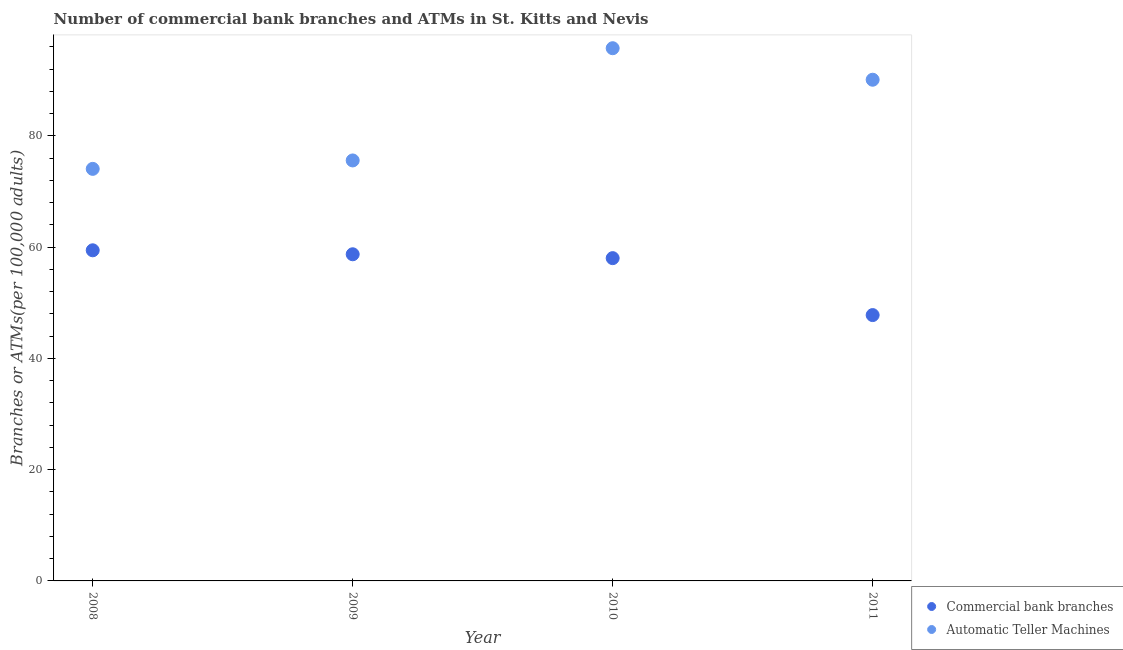Is the number of dotlines equal to the number of legend labels?
Keep it short and to the point. Yes. What is the number of commercal bank branches in 2009?
Your answer should be very brief. 58.73. Across all years, what is the maximum number of atms?
Your answer should be compact. 95.77. Across all years, what is the minimum number of atms?
Offer a very short reply. 74.08. In which year was the number of atms minimum?
Your response must be concise. 2008. What is the total number of atms in the graph?
Your response must be concise. 335.55. What is the difference between the number of atms in 2010 and that in 2011?
Provide a succinct answer. 5.67. What is the difference between the number of atms in 2010 and the number of commercal bank branches in 2009?
Offer a very short reply. 37.04. What is the average number of atms per year?
Ensure brevity in your answer.  83.89. In the year 2010, what is the difference between the number of commercal bank branches and number of atms?
Your answer should be compact. -37.74. What is the ratio of the number of atms in 2009 to that in 2011?
Make the answer very short. 0.84. What is the difference between the highest and the second highest number of atms?
Give a very brief answer. 5.67. What is the difference between the highest and the lowest number of atms?
Your answer should be very brief. 21.69. In how many years, is the number of commercal bank branches greater than the average number of commercal bank branches taken over all years?
Offer a very short reply. 3. Is the sum of the number of atms in 2008 and 2009 greater than the maximum number of commercal bank branches across all years?
Offer a very short reply. Yes. Is the number of commercal bank branches strictly greater than the number of atms over the years?
Make the answer very short. No. Is the number of atms strictly less than the number of commercal bank branches over the years?
Your answer should be very brief. No. How many dotlines are there?
Offer a very short reply. 2. What is the difference between two consecutive major ticks on the Y-axis?
Keep it short and to the point. 20. Where does the legend appear in the graph?
Ensure brevity in your answer.  Bottom right. How many legend labels are there?
Offer a terse response. 2. How are the legend labels stacked?
Make the answer very short. Vertical. What is the title of the graph?
Offer a terse response. Number of commercial bank branches and ATMs in St. Kitts and Nevis. Does "Measles" appear as one of the legend labels in the graph?
Keep it short and to the point. No. What is the label or title of the Y-axis?
Provide a short and direct response. Branches or ATMs(per 100,0 adults). What is the Branches or ATMs(per 100,000 adults) in Commercial bank branches in 2008?
Your answer should be compact. 59.44. What is the Branches or ATMs(per 100,000 adults) in Automatic Teller Machines in 2008?
Ensure brevity in your answer.  74.08. What is the Branches or ATMs(per 100,000 adults) in Commercial bank branches in 2009?
Offer a very short reply. 58.73. What is the Branches or ATMs(per 100,000 adults) of Automatic Teller Machines in 2009?
Your response must be concise. 75.59. What is the Branches or ATMs(per 100,000 adults) in Commercial bank branches in 2010?
Make the answer very short. 58.03. What is the Branches or ATMs(per 100,000 adults) of Automatic Teller Machines in 2010?
Offer a very short reply. 95.77. What is the Branches or ATMs(per 100,000 adults) of Commercial bank branches in 2011?
Provide a succinct answer. 47.79. What is the Branches or ATMs(per 100,000 adults) of Automatic Teller Machines in 2011?
Give a very brief answer. 90.1. Across all years, what is the maximum Branches or ATMs(per 100,000 adults) in Commercial bank branches?
Make the answer very short. 59.44. Across all years, what is the maximum Branches or ATMs(per 100,000 adults) in Automatic Teller Machines?
Offer a terse response. 95.77. Across all years, what is the minimum Branches or ATMs(per 100,000 adults) of Commercial bank branches?
Ensure brevity in your answer.  47.79. Across all years, what is the minimum Branches or ATMs(per 100,000 adults) in Automatic Teller Machines?
Offer a terse response. 74.08. What is the total Branches or ATMs(per 100,000 adults) of Commercial bank branches in the graph?
Offer a terse response. 223.99. What is the total Branches or ATMs(per 100,000 adults) in Automatic Teller Machines in the graph?
Offer a very short reply. 335.55. What is the difference between the Branches or ATMs(per 100,000 adults) of Commercial bank branches in 2008 and that in 2009?
Offer a terse response. 0.71. What is the difference between the Branches or ATMs(per 100,000 adults) in Automatic Teller Machines in 2008 and that in 2009?
Your answer should be compact. -1.51. What is the difference between the Branches or ATMs(per 100,000 adults) of Commercial bank branches in 2008 and that in 2010?
Offer a very short reply. 1.41. What is the difference between the Branches or ATMs(per 100,000 adults) in Automatic Teller Machines in 2008 and that in 2010?
Your answer should be compact. -21.69. What is the difference between the Branches or ATMs(per 100,000 adults) in Commercial bank branches in 2008 and that in 2011?
Your response must be concise. 11.65. What is the difference between the Branches or ATMs(per 100,000 adults) of Automatic Teller Machines in 2008 and that in 2011?
Offer a very short reply. -16.02. What is the difference between the Branches or ATMs(per 100,000 adults) in Commercial bank branches in 2009 and that in 2010?
Ensure brevity in your answer.  0.7. What is the difference between the Branches or ATMs(per 100,000 adults) in Automatic Teller Machines in 2009 and that in 2010?
Provide a short and direct response. -20.18. What is the difference between the Branches or ATMs(per 100,000 adults) in Commercial bank branches in 2009 and that in 2011?
Make the answer very short. 10.93. What is the difference between the Branches or ATMs(per 100,000 adults) of Automatic Teller Machines in 2009 and that in 2011?
Offer a terse response. -14.51. What is the difference between the Branches or ATMs(per 100,000 adults) in Commercial bank branches in 2010 and that in 2011?
Offer a very short reply. 10.24. What is the difference between the Branches or ATMs(per 100,000 adults) of Automatic Teller Machines in 2010 and that in 2011?
Offer a very short reply. 5.67. What is the difference between the Branches or ATMs(per 100,000 adults) in Commercial bank branches in 2008 and the Branches or ATMs(per 100,000 adults) in Automatic Teller Machines in 2009?
Make the answer very short. -16.15. What is the difference between the Branches or ATMs(per 100,000 adults) of Commercial bank branches in 2008 and the Branches or ATMs(per 100,000 adults) of Automatic Teller Machines in 2010?
Keep it short and to the point. -36.33. What is the difference between the Branches or ATMs(per 100,000 adults) of Commercial bank branches in 2008 and the Branches or ATMs(per 100,000 adults) of Automatic Teller Machines in 2011?
Your answer should be very brief. -30.66. What is the difference between the Branches or ATMs(per 100,000 adults) of Commercial bank branches in 2009 and the Branches or ATMs(per 100,000 adults) of Automatic Teller Machines in 2010?
Provide a succinct answer. -37.04. What is the difference between the Branches or ATMs(per 100,000 adults) of Commercial bank branches in 2009 and the Branches or ATMs(per 100,000 adults) of Automatic Teller Machines in 2011?
Your answer should be very brief. -31.38. What is the difference between the Branches or ATMs(per 100,000 adults) of Commercial bank branches in 2010 and the Branches or ATMs(per 100,000 adults) of Automatic Teller Machines in 2011?
Ensure brevity in your answer.  -32.07. What is the average Branches or ATMs(per 100,000 adults) of Commercial bank branches per year?
Ensure brevity in your answer.  56. What is the average Branches or ATMs(per 100,000 adults) in Automatic Teller Machines per year?
Make the answer very short. 83.89. In the year 2008, what is the difference between the Branches or ATMs(per 100,000 adults) of Commercial bank branches and Branches or ATMs(per 100,000 adults) of Automatic Teller Machines?
Your answer should be very brief. -14.64. In the year 2009, what is the difference between the Branches or ATMs(per 100,000 adults) of Commercial bank branches and Branches or ATMs(per 100,000 adults) of Automatic Teller Machines?
Ensure brevity in your answer.  -16.87. In the year 2010, what is the difference between the Branches or ATMs(per 100,000 adults) in Commercial bank branches and Branches or ATMs(per 100,000 adults) in Automatic Teller Machines?
Your answer should be very brief. -37.74. In the year 2011, what is the difference between the Branches or ATMs(per 100,000 adults) in Commercial bank branches and Branches or ATMs(per 100,000 adults) in Automatic Teller Machines?
Give a very brief answer. -42.31. What is the ratio of the Branches or ATMs(per 100,000 adults) in Commercial bank branches in 2008 to that in 2009?
Ensure brevity in your answer.  1.01. What is the ratio of the Branches or ATMs(per 100,000 adults) in Automatic Teller Machines in 2008 to that in 2009?
Your response must be concise. 0.98. What is the ratio of the Branches or ATMs(per 100,000 adults) in Commercial bank branches in 2008 to that in 2010?
Keep it short and to the point. 1.02. What is the ratio of the Branches or ATMs(per 100,000 adults) of Automatic Teller Machines in 2008 to that in 2010?
Your answer should be very brief. 0.77. What is the ratio of the Branches or ATMs(per 100,000 adults) of Commercial bank branches in 2008 to that in 2011?
Your answer should be compact. 1.24. What is the ratio of the Branches or ATMs(per 100,000 adults) in Automatic Teller Machines in 2008 to that in 2011?
Offer a very short reply. 0.82. What is the ratio of the Branches or ATMs(per 100,000 adults) of Commercial bank branches in 2009 to that in 2010?
Your answer should be very brief. 1.01. What is the ratio of the Branches or ATMs(per 100,000 adults) in Automatic Teller Machines in 2009 to that in 2010?
Make the answer very short. 0.79. What is the ratio of the Branches or ATMs(per 100,000 adults) in Commercial bank branches in 2009 to that in 2011?
Keep it short and to the point. 1.23. What is the ratio of the Branches or ATMs(per 100,000 adults) in Automatic Teller Machines in 2009 to that in 2011?
Your response must be concise. 0.84. What is the ratio of the Branches or ATMs(per 100,000 adults) of Commercial bank branches in 2010 to that in 2011?
Offer a terse response. 1.21. What is the ratio of the Branches or ATMs(per 100,000 adults) in Automatic Teller Machines in 2010 to that in 2011?
Ensure brevity in your answer.  1.06. What is the difference between the highest and the second highest Branches or ATMs(per 100,000 adults) of Commercial bank branches?
Provide a succinct answer. 0.71. What is the difference between the highest and the second highest Branches or ATMs(per 100,000 adults) of Automatic Teller Machines?
Give a very brief answer. 5.67. What is the difference between the highest and the lowest Branches or ATMs(per 100,000 adults) of Commercial bank branches?
Offer a terse response. 11.65. What is the difference between the highest and the lowest Branches or ATMs(per 100,000 adults) of Automatic Teller Machines?
Provide a succinct answer. 21.69. 